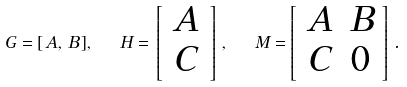<formula> <loc_0><loc_0><loc_500><loc_500>G = [ \, A , \, B \, ] , \ \ H = \, \left [ \, \begin{array} { c } A \\ C \end{array} \, \right ] \, , \ \ M = \left [ \, \begin{array} { c c } A & B \\ C & 0 \end{array} \, \right ] \, .</formula> 